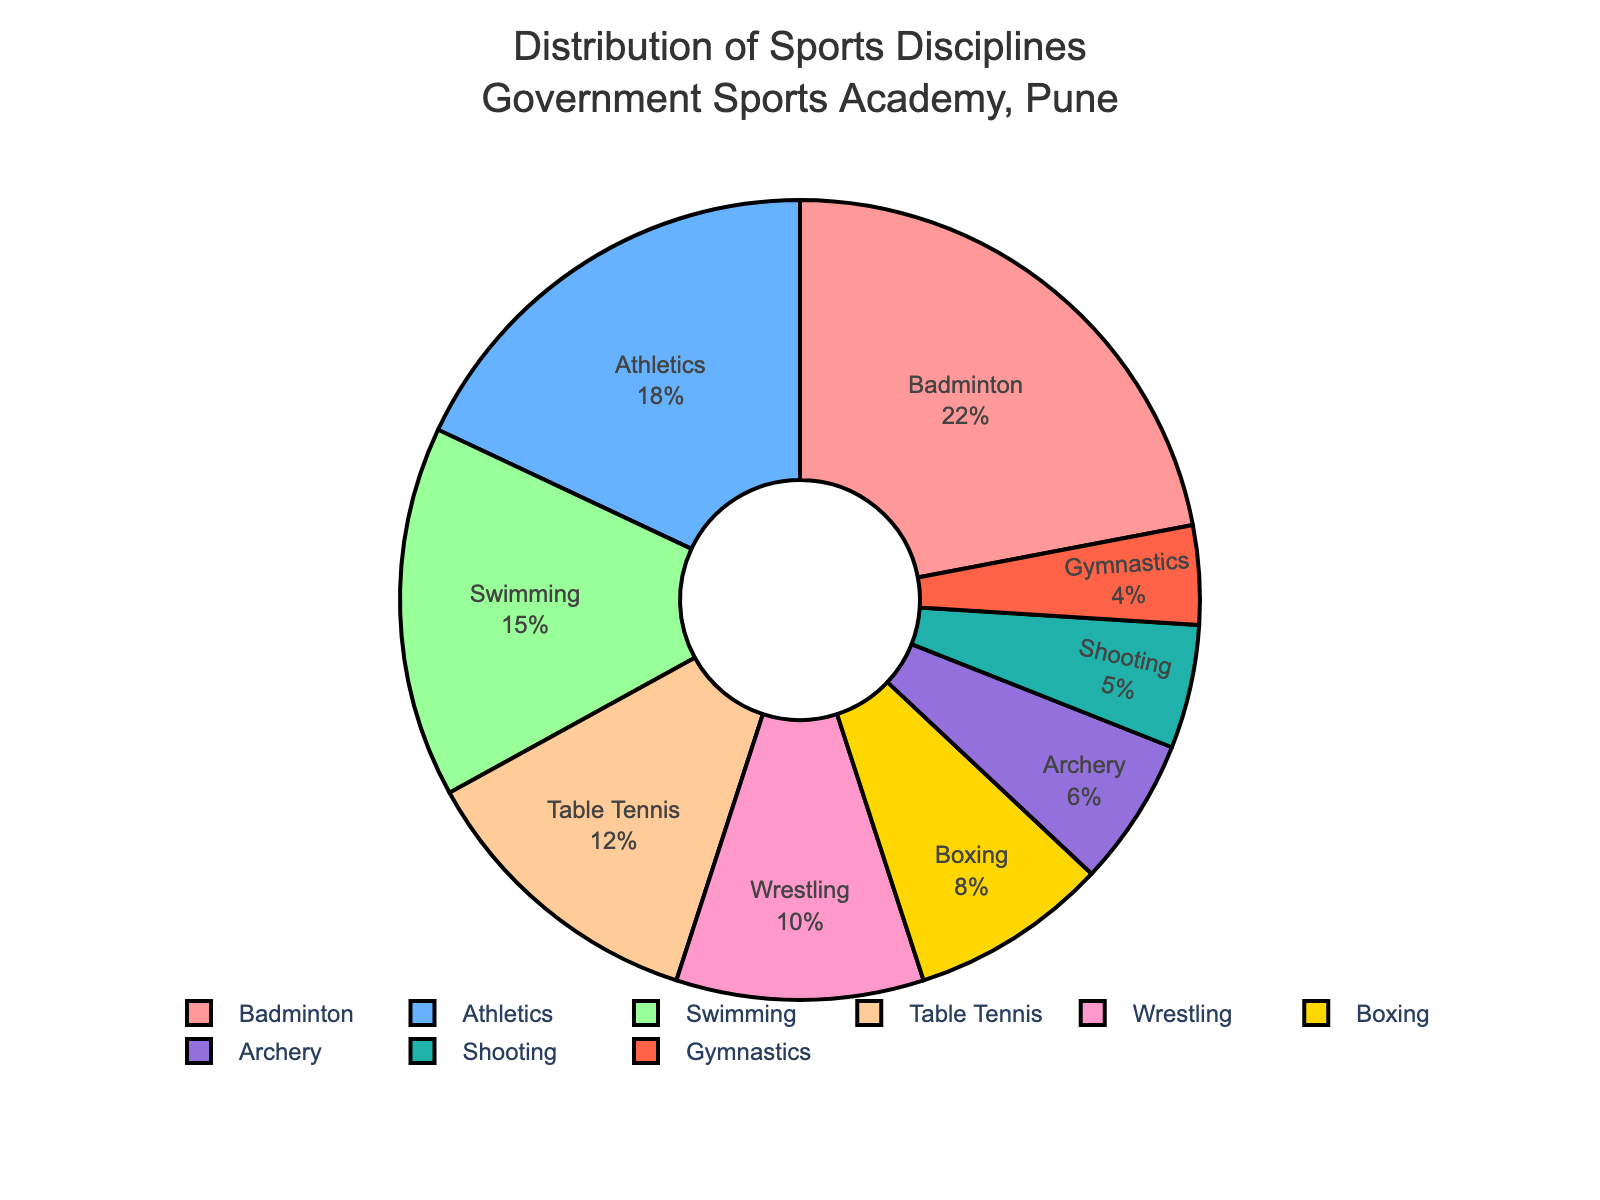What's the percentage of the top three most popular sports combined? The top three sports by percentage are Badminton (22%), Athletics (18%), and Swimming (15%). Adding these percentages gives 22 + 18 + 15 = 55%.
Answer: 55% Which sport has the smallest representation, and what is its percentage? By looking at the smallest segment in the pie chart, Gymnastics has the smallest representation with 4%.
Answer: Gymnastics, 4% Are there more people in Wrestling or Boxing? By what percentage? From the pie chart, Wrestling has 10%, and Boxing has 8%. To find the difference, subtract 8 from 10, yielding 10 - 8 = 2%. Therefore, Wrestling has 2% more representation than Boxing.
Answer: Wrestling by 2% What is the combined percentage of sports with less than 10% representation each? The sports with less than 10% representation are Boxing (8%), Archery (6%), Shooting (5%), and Gymnastics (4%). Adding these percentages gives 8 + 6 + 5 + 4 = 23%.
Answer: 23% Which sport is represented by the second biggest segment in the pie chart? The second biggest segment in the pie chart belongs to Athletics, which has 18%.
Answer: Athletics Which sport has more participants, Shooting or Archery? By comparing the segments, Archery has 6%, and Shooting has 5%. Therefore, Archery has more participants.
Answer: Archery If the percentages of Badminton and Table Tennis were swapped, how much larger would Badminton's percentage be? Currently, Badminton has 22% and Table Tennis has 12%. If they were swapped, Badminton would have 12% and Table Tennis would have 22%. The difference is 22 - 12 = 10%.
Answer: 10% What percentage less than Athletics is Swimming? Athletics has 18%, and Swimming has 15%. To find the percentage difference, 18 - 15 = 3%. Therefore, Swimming is 3% less than Athletics.
Answer: 3% How many sports have a representation above 10%? From the pie chart, the sports above 10% representation are Badminton (22%), Athletics (18%), Swimming (15%), and Table Tennis (12%). Thus, there are four sports above 10%.
Answer: 4 Which sport has a representation closest to the average percentage across all sports? To find the average percentage, you sum all percentages, which is 100 (since it's a complete pie chart) and divide by the number of sports (9). This gives 100/9 ≈ 11.11%. The percentage closest to this average is Table Tennis, with 12%.
Answer: Table Tennis 